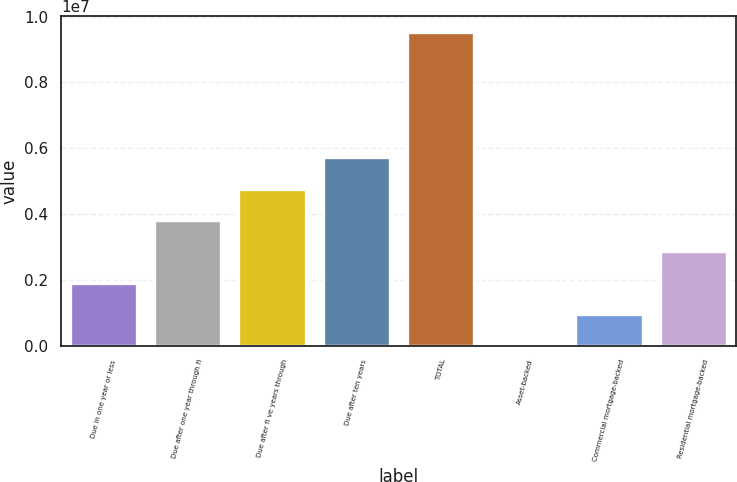<chart> <loc_0><loc_0><loc_500><loc_500><bar_chart><fcel>Due in one year or less<fcel>Due after one year through fi<fcel>Due after fi ve years through<fcel>Due after ten years<fcel>TOTAL<fcel>Asset-backed<fcel>Commercial mortgage-backed<fcel>Residential mortgage-backed<nl><fcel>1.91129e+06<fcel>3.81826e+06<fcel>4.77175e+06<fcel>5.72524e+06<fcel>9.53918e+06<fcel>4320<fcel>957806<fcel>2.86478e+06<nl></chart> 